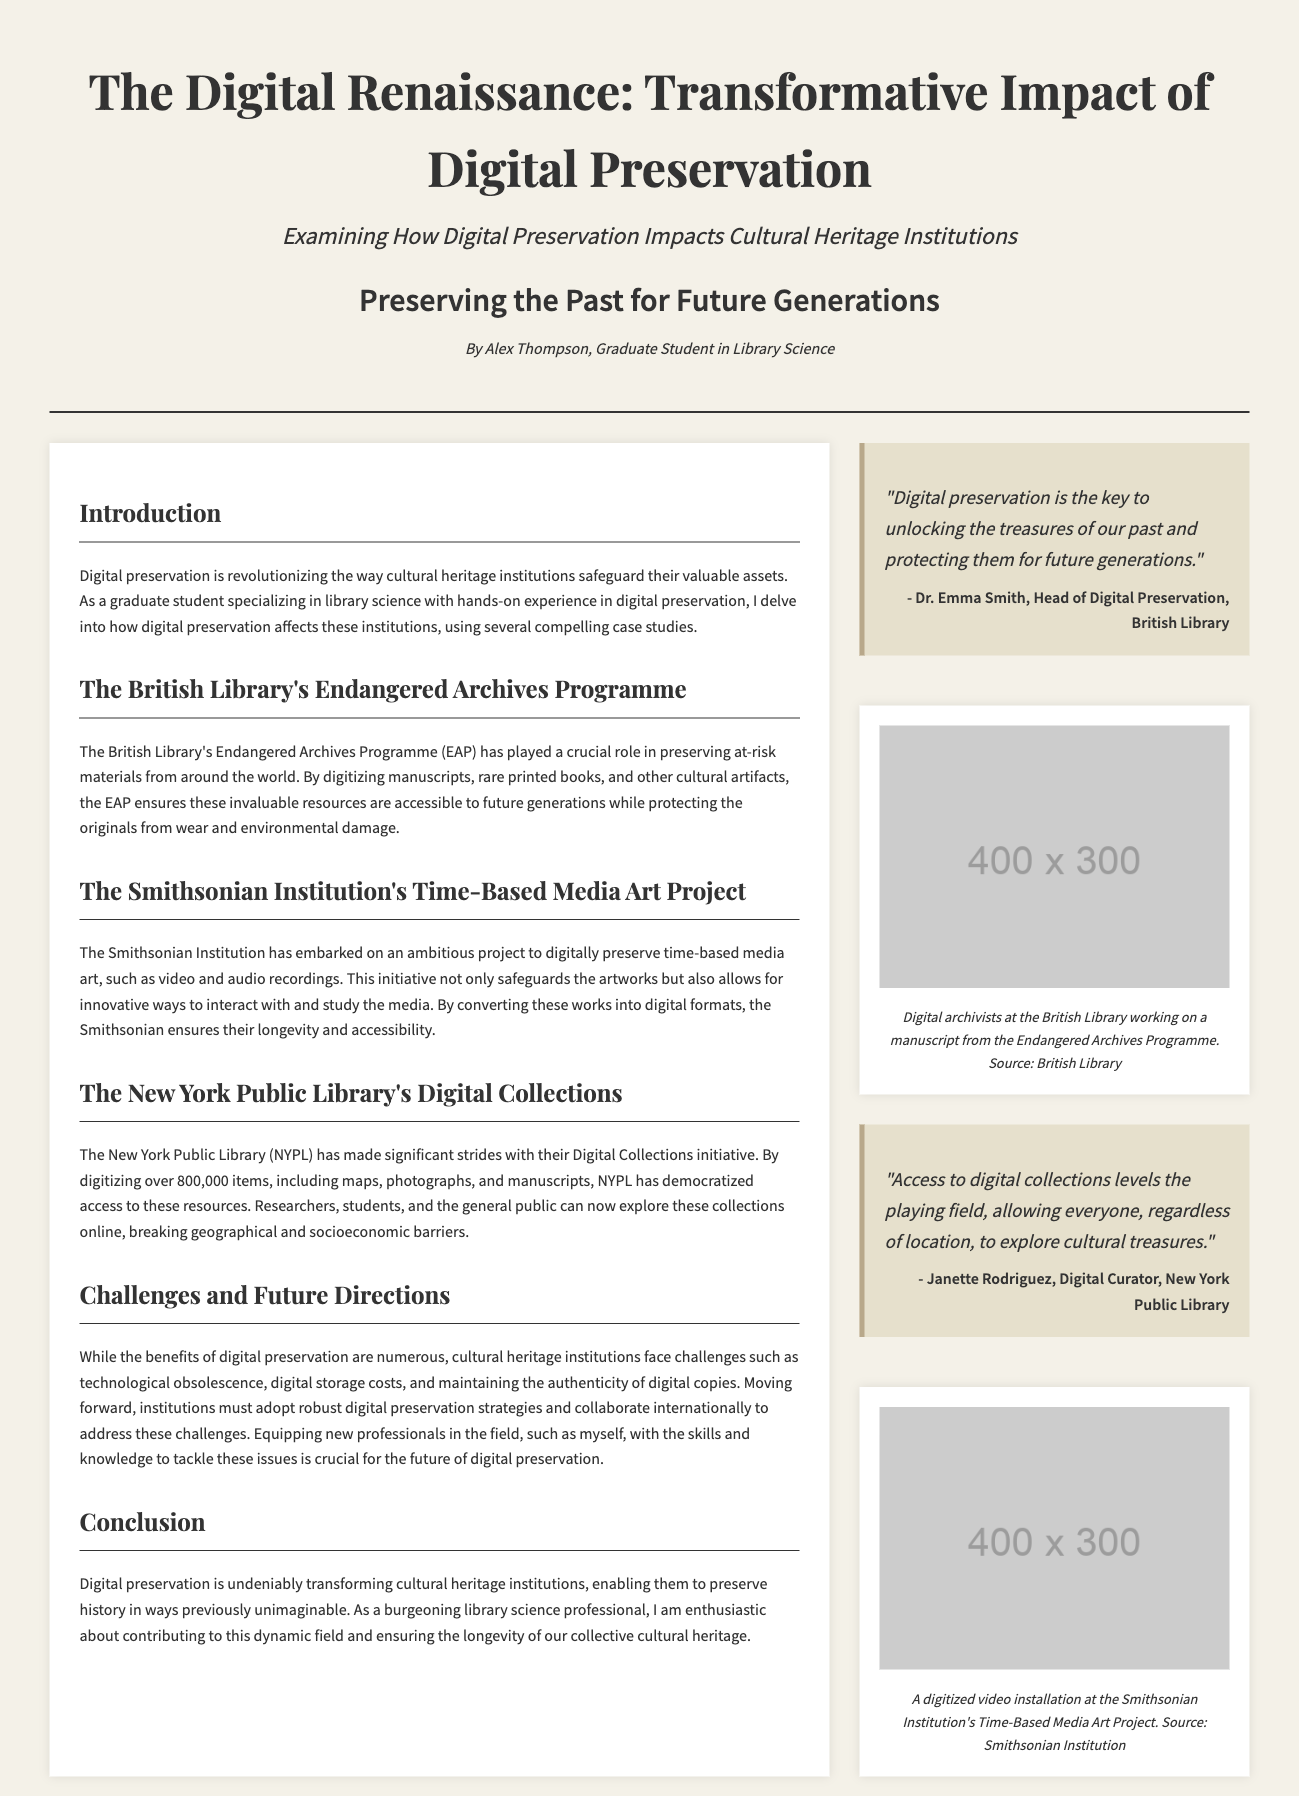What is the title of the document? The title of the document is prominently displayed at the top of the page.
Answer: The Digital Renaissance: Transformative Impact of Digital Preservation Who is the author of the article? The author information is provided in the byline section.
Answer: Alex Thompson What program is mentioned in connection with the British Library? The document details the specific program associated with the British Library.
Answer: Endangered Archives Programme How many items has the New York Public Library digitized? The text provides a specific number related to the NYPL's digitization efforts.
Answer: over 800,000 What quote is provided by Dr. Emma Smith? A notable quote from Dr. Emma Smith is featured in the sidebar.
Answer: "Digital preservation is the key to unlocking the treasures of our past and protecting them for future generations." What is one challenge cultural heritage institutions face in digital preservation? The document discusses challenges faced by these institutions, requiring synthesis of information in the section.
Answer: Technological obsolescence What project is the Smithsonian Institution working on? The document outlines the main project undertaken by the Smithsonian Institution.
Answer: Time-Based Media Art Project What does the sidebar image depict? The description under the image explains its content.
Answer: Digital archivists at the British Library working on a manuscript from the Endangered Archives Programme 